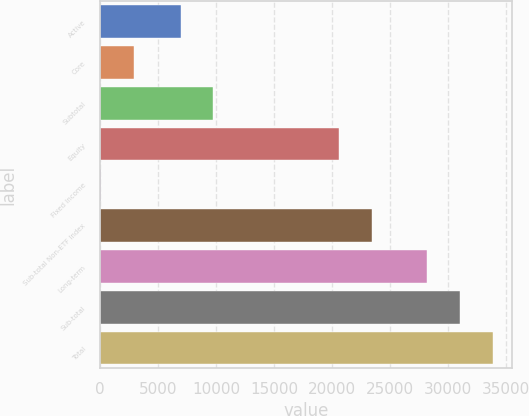<chart> <loc_0><loc_0><loc_500><loc_500><bar_chart><fcel>Active<fcel>Core<fcel>Subtotal<fcel>Equity<fcel>Fixed Income<fcel>Sub-total Non-ETF Index<fcel>Long-term<fcel>Sub-total<fcel>Total<nl><fcel>6943<fcel>2926.8<fcel>9756.8<fcel>20630<fcel>113<fcel>23443.8<fcel>28251<fcel>31064.8<fcel>33878.6<nl></chart> 